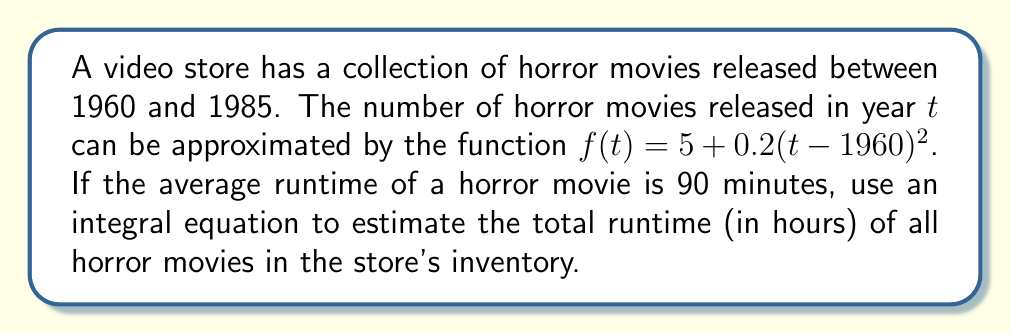Could you help me with this problem? To solve this problem, we'll follow these steps:

1) First, we need to set up an integral equation to calculate the total number of horror movies from 1960 to 1985:

   $$N = \int_{1960}^{1985} f(t) dt = \int_{1960}^{1985} (5 + 0.2(t-1960)^2) dt$$

2) Let's solve this integral:
   
   $$N = \int_{1960}^{1985} 5 dt + 0.2 \int_{1960}^{1985} (t-1960)^2 dt$$
   
   $$N = 5t \bigg|_{1960}^{1985} + 0.2 \cdot \frac{(t-1960)^3}{3} \bigg|_{1960}^{1985}$$
   
   $$N = 5(1985-1960) + 0.2 \cdot \frac{25^3}{3}$$
   
   $$N = 125 + 1041.67 = 1166.67$$

3) This gives us the total number of horror movies. To get the total runtime in minutes, we multiply by 90:

   $$Total\ runtime\ (minutes) = 1166.67 \cdot 90 = 105,000\ minutes$$

4) To convert to hours, we divide by 60:

   $$Total\ runtime\ (hours) = 105,000 / 60 = 1,750\ hours$$
Answer: 1,750 hours 